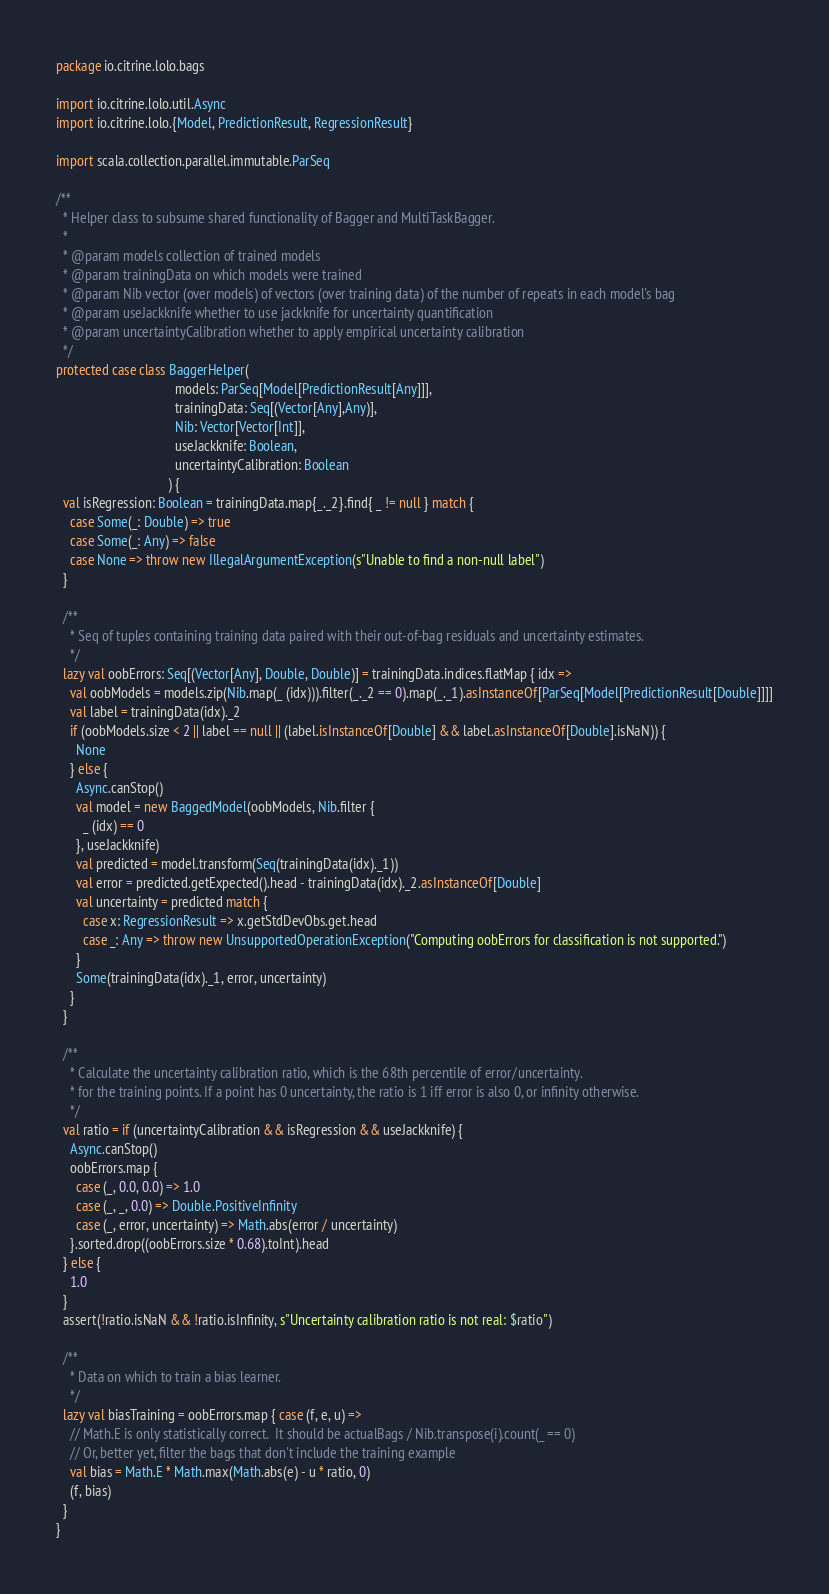<code> <loc_0><loc_0><loc_500><loc_500><_Scala_>package io.citrine.lolo.bags

import io.citrine.lolo.util.Async
import io.citrine.lolo.{Model, PredictionResult, RegressionResult}

import scala.collection.parallel.immutable.ParSeq

/**
  * Helper class to subsume shared functionality of Bagger and MultiTaskBagger.
  *
  * @param models collection of trained models
  * @param trainingData on which models were trained
  * @param Nib vector (over models) of vectors (over training data) of the number of repeats in each model's bag
  * @param useJackknife whether to use jackknife for uncertainty quantification
  * @param uncertaintyCalibration whether to apply empirical uncertainty calibration
  */
protected case class BaggerHelper(
                                   models: ParSeq[Model[PredictionResult[Any]]],
                                   trainingData: Seq[(Vector[Any],Any)],
                                   Nib: Vector[Vector[Int]],
                                   useJackknife: Boolean,
                                   uncertaintyCalibration: Boolean
                                 ) {
  val isRegression: Boolean = trainingData.map{_._2}.find{ _ != null } match {
    case Some(_: Double) => true
    case Some(_: Any) => false
    case None => throw new IllegalArgumentException(s"Unable to find a non-null label")
  }

  /**
    * Seq of tuples containing training data paired with their out-of-bag residuals and uncertainty estimates.
    */
  lazy val oobErrors: Seq[(Vector[Any], Double, Double)] = trainingData.indices.flatMap { idx =>
    val oobModels = models.zip(Nib.map(_ (idx))).filter(_._2 == 0).map(_._1).asInstanceOf[ParSeq[Model[PredictionResult[Double]]]]
    val label = trainingData(idx)._2
    if (oobModels.size < 2 || label == null || (label.isInstanceOf[Double] && label.asInstanceOf[Double].isNaN)) {
      None
    } else {
      Async.canStop()
      val model = new BaggedModel(oobModels, Nib.filter {
        _ (idx) == 0
      }, useJackknife)
      val predicted = model.transform(Seq(trainingData(idx)._1))
      val error = predicted.getExpected().head - trainingData(idx)._2.asInstanceOf[Double]
      val uncertainty = predicted match {
        case x: RegressionResult => x.getStdDevObs.get.head
        case _: Any => throw new UnsupportedOperationException("Computing oobErrors for classification is not supported.")
      }
      Some(trainingData(idx)._1, error, uncertainty)
    }
  }

  /**
    * Calculate the uncertainty calibration ratio, which is the 68th percentile of error/uncertainty.
    * for the training points. If a point has 0 uncertainty, the ratio is 1 iff error is also 0, or infinity otherwise.
    */
  val ratio = if (uncertaintyCalibration && isRegression && useJackknife) {
    Async.canStop()
    oobErrors.map {
      case (_, 0.0, 0.0) => 1.0
      case (_, _, 0.0) => Double.PositiveInfinity
      case (_, error, uncertainty) => Math.abs(error / uncertainty)
    }.sorted.drop((oobErrors.size * 0.68).toInt).head
  } else {
    1.0
  }
  assert(!ratio.isNaN && !ratio.isInfinity, s"Uncertainty calibration ratio is not real: $ratio")

  /**
    * Data on which to train a bias learner.
    */
  lazy val biasTraining = oobErrors.map { case (f, e, u) =>
    // Math.E is only statistically correct.  It should be actualBags / Nib.transpose(i).count(_ == 0)
    // Or, better yet, filter the bags that don't include the training example
    val bias = Math.E * Math.max(Math.abs(e) - u * ratio, 0)
    (f, bias)
  }
}
</code> 